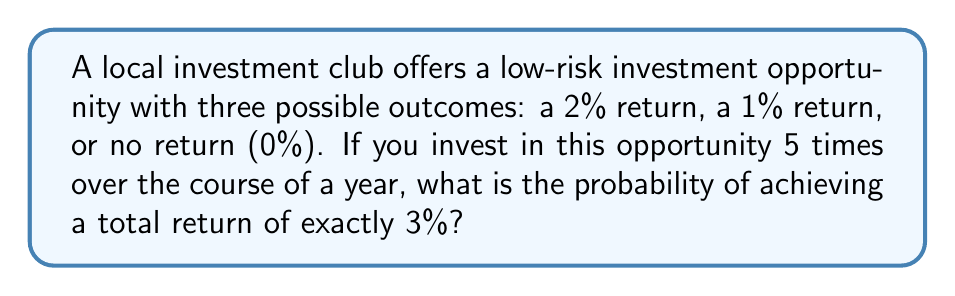Teach me how to tackle this problem. Let's approach this step-by-step:

1) First, we need to identify the possible combinations that would result in a 3% total return. These are:
   - One 2% return and one 1% return
   - Three 1% returns

2) Let's calculate the number of ways each of these can occur:

   a) One 2% return and one 1% return:
      We need to choose 1 position for the 2% return out of 5, and 1 position for the 1% return out of the remaining 4.
      This can be done in $\binom{5}{1} \cdot \binom{4}{1} = 5 \cdot 4 = 20$ ways.

   b) Three 1% returns:
      We need to choose 3 positions for the 1% returns out of 5.
      This can be done in $\binom{5}{3} = 10$ ways.

3) Now, let's calculate the probability of each outcome:
   - Probability of 2% return: $\frac{1}{3}$
   - Probability of 1% return: $\frac{1}{3}$
   - Probability of 0% return: $\frac{1}{3}$

4) For scenario (a), the probability is:
   $20 \cdot (\frac{1}{3})^1 \cdot (\frac{1}{3})^1 \cdot (\frac{1}{3})^3 = \frac{20}{243}$

5) For scenario (b), the probability is:
   $10 \cdot (\frac{1}{3})^3 \cdot (\frac{1}{3})^2 = \frac{10}{243}$

6) The total probability is the sum of these two scenarios:
   $\frac{20}{243} + \frac{10}{243} = \frac{30}{243} = \frac{10}{81}$

Therefore, the probability of achieving exactly a 3% return over 5 investments is $\frac{10}{81}$.
Answer: $\frac{10}{81}$ or approximately 0.1235 (12.35%) 